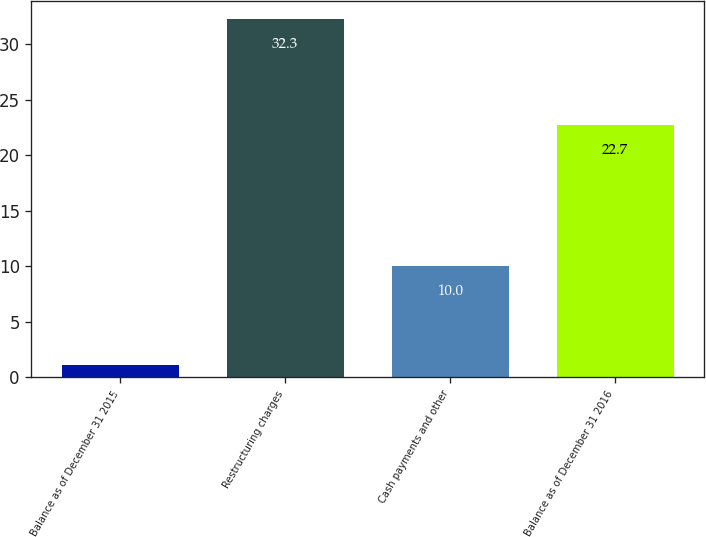Convert chart to OTSL. <chart><loc_0><loc_0><loc_500><loc_500><bar_chart><fcel>Balance as of December 31 2015<fcel>Restructuring charges<fcel>Cash payments and other<fcel>Balance as of December 31 2016<nl><fcel>1.1<fcel>32.3<fcel>10<fcel>22.7<nl></chart> 